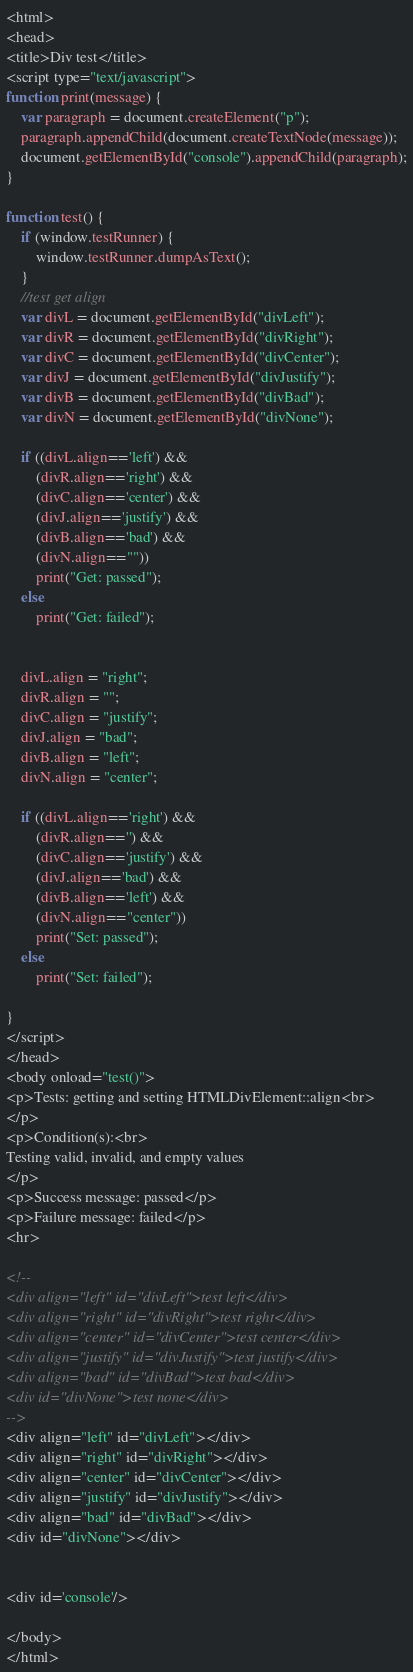<code> <loc_0><loc_0><loc_500><loc_500><_HTML_><html>
<head>
<title>Div test</title>
<script type="text/javascript">
function print(message) {
	var paragraph = document.createElement("p");
	paragraph.appendChild(document.createTextNode(message));
	document.getElementById("console").appendChild(paragraph);
}

function test() {
	if (window.testRunner) {
		window.testRunner.dumpAsText();
	}
	//test get align
	var divL = document.getElementById("divLeft");
	var divR = document.getElementById("divRight");
	var divC = document.getElementById("divCenter");
	var divJ = document.getElementById("divJustify");
	var divB = document.getElementById("divBad");
	var divN = document.getElementById("divNone");
	
	if ((divL.align=='left') &&
		(divR.align=='right') &&
		(divC.align=='center') &&
		(divJ.align=='justify') &&
		(divB.align=='bad') &&
		(divN.align==""))
		print("Get: passed");
	else
		print("Get: failed");
	
	
	divL.align = "right";
	divR.align = "";
	divC.align = "justify";
	divJ.align = "bad";
	divB.align = "left";
	divN.align = "center";
	
	if ((divL.align=='right') &&
		(divR.align=='') &&
		(divC.align=='justify') &&
		(divJ.align=='bad') &&
		(divB.align=='left') &&
		(divN.align=="center"))
		print("Set: passed");
	else
		print("Set: failed");
	
}
</script>
</head>
<body onload="test()">
<p>Tests: getting and setting HTMLDivElement::align<br>
</p>
<p>Condition(s):<br>
Testing valid, invalid, and empty values
</p>
<p>Success message: passed</p>
<p>Failure message: failed</p>
<hr>

<!--
<div align="left" id="divLeft">test left</div>
<div align="right" id="divRight">test right</div>
<div align="center" id="divCenter">test center</div>
<div align="justify" id="divJustify">test justify</div>
<div align="bad" id="divBad">test bad</div>
<div id="divNone">test none</div>
-->
<div align="left" id="divLeft"></div>
<div align="right" id="divRight"></div>
<div align="center" id="divCenter"></div>
<div align="justify" id="divJustify"></div>
<div align="bad" id="divBad"></div>
<div id="divNone"></div>


<div id='console'/>

</body>
</html>
</code> 